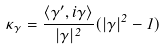Convert formula to latex. <formula><loc_0><loc_0><loc_500><loc_500>\kappa _ { \gamma } = \frac { \langle \gamma ^ { \prime } , i \gamma \rangle } { | \gamma | ^ { 2 } } ( | \gamma | ^ { 2 } - 1 )</formula> 